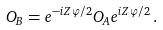Convert formula to latex. <formula><loc_0><loc_0><loc_500><loc_500>O _ { B } = e ^ { - i Z \varphi / 2 } O _ { A } e ^ { i Z \varphi / 2 } \, .</formula> 